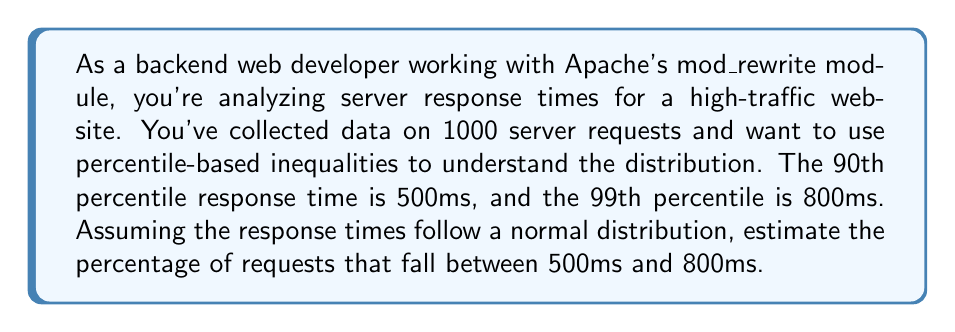Could you help me with this problem? To solve this problem, we'll use the properties of normal distribution and percentiles:

1) In a normal distribution, the 90th percentile corresponds to approximately 1.28 standard deviations above the mean, and the 99th percentile corresponds to approximately 2.33 standard deviations above the mean.

2) Let $\mu$ be the mean and $\sigma$ be the standard deviation of the distribution. We can write two equations:

   $$\mu + 1.28\sigma = 500$$
   $$\mu + 2.33\sigma = 800$$

3) Subtracting the first equation from the second:

   $$1.05\sigma = 300$$
   $$\sigma \approx 285.71$$

4) Substituting this back into either equation:

   $$\mu + 1.28(285.71) = 500$$
   $$\mu \approx 134.29$$

5) Now, we need to find the z-scores for 500ms and 800ms:

   $$z_{500} = \frac{500 - 134.29}{285.71} \approx 1.28$$
   $$z_{800} = \frac{800 - 134.29}{285.71} \approx 2.33$$

6) The area between these z-scores in a standard normal distribution represents the percentage we're looking for. We can find this using a standard normal table or a calculator:

   $$P(1.28 < Z < 2.33) = P(Z < 2.33) - P(Z < 1.28)$$
   $$= 0.9901 - 0.8997 = 0.0904$$

7) Converting to a percentage:

   $$0.0904 * 100 = 9.04\%$$
Answer: Approximately 9.04% of requests fall between 500ms and 800ms. 